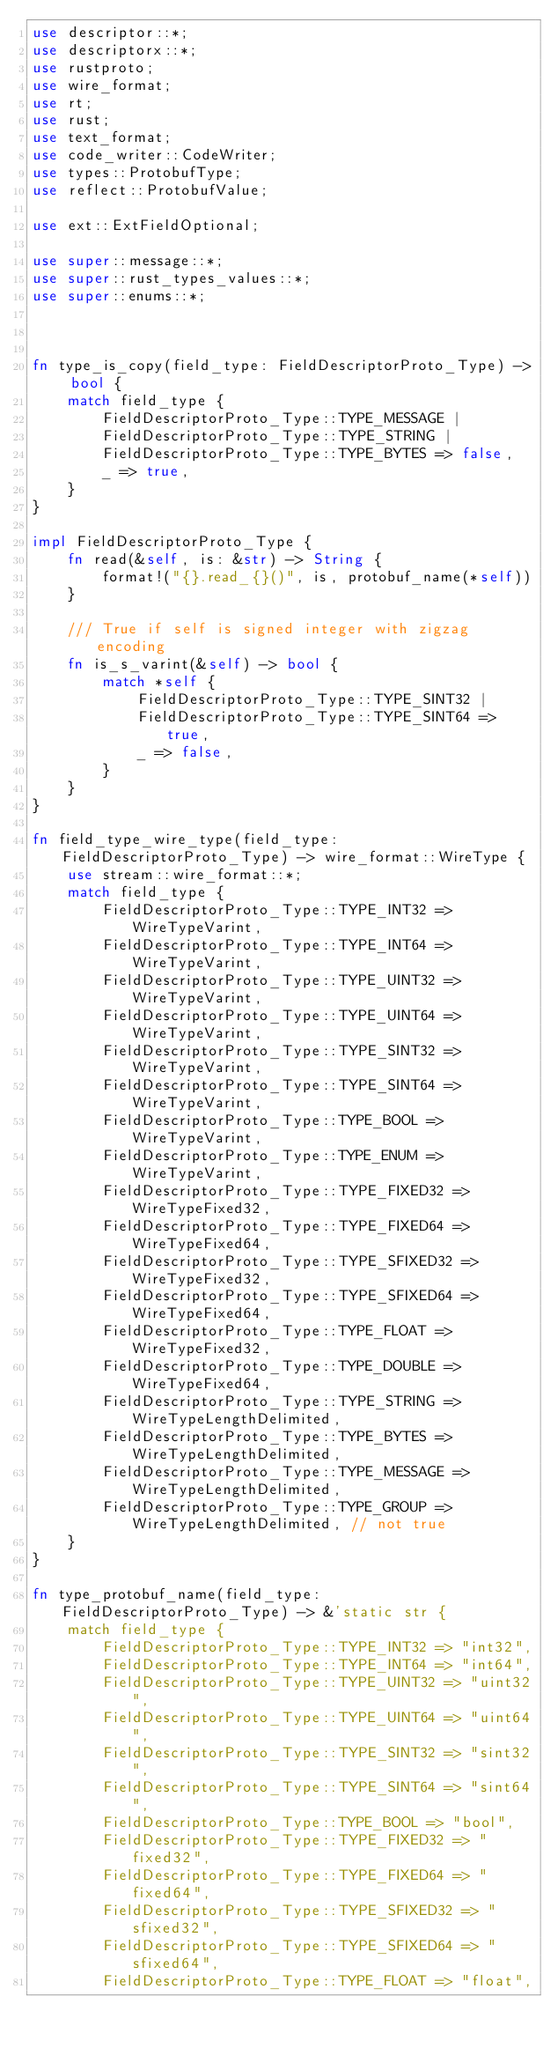Convert code to text. <code><loc_0><loc_0><loc_500><loc_500><_Rust_>use descriptor::*;
use descriptorx::*;
use rustproto;
use wire_format;
use rt;
use rust;
use text_format;
use code_writer::CodeWriter;
use types::ProtobufType;
use reflect::ProtobufValue;

use ext::ExtFieldOptional;

use super::message::*;
use super::rust_types_values::*;
use super::enums::*;



fn type_is_copy(field_type: FieldDescriptorProto_Type) -> bool {
    match field_type {
        FieldDescriptorProto_Type::TYPE_MESSAGE |
        FieldDescriptorProto_Type::TYPE_STRING |
        FieldDescriptorProto_Type::TYPE_BYTES => false,
        _ => true,
    }
}

impl FieldDescriptorProto_Type {
    fn read(&self, is: &str) -> String {
        format!("{}.read_{}()", is, protobuf_name(*self))
    }

    /// True if self is signed integer with zigzag encoding
    fn is_s_varint(&self) -> bool {
        match *self {
            FieldDescriptorProto_Type::TYPE_SINT32 |
            FieldDescriptorProto_Type::TYPE_SINT64 => true,
            _ => false,
        }
    }
}

fn field_type_wire_type(field_type: FieldDescriptorProto_Type) -> wire_format::WireType {
    use stream::wire_format::*;
    match field_type {
        FieldDescriptorProto_Type::TYPE_INT32 => WireTypeVarint,
        FieldDescriptorProto_Type::TYPE_INT64 => WireTypeVarint,
        FieldDescriptorProto_Type::TYPE_UINT32 => WireTypeVarint,
        FieldDescriptorProto_Type::TYPE_UINT64 => WireTypeVarint,
        FieldDescriptorProto_Type::TYPE_SINT32 => WireTypeVarint,
        FieldDescriptorProto_Type::TYPE_SINT64 => WireTypeVarint,
        FieldDescriptorProto_Type::TYPE_BOOL => WireTypeVarint,
        FieldDescriptorProto_Type::TYPE_ENUM => WireTypeVarint,
        FieldDescriptorProto_Type::TYPE_FIXED32 => WireTypeFixed32,
        FieldDescriptorProto_Type::TYPE_FIXED64 => WireTypeFixed64,
        FieldDescriptorProto_Type::TYPE_SFIXED32 => WireTypeFixed32,
        FieldDescriptorProto_Type::TYPE_SFIXED64 => WireTypeFixed64,
        FieldDescriptorProto_Type::TYPE_FLOAT => WireTypeFixed32,
        FieldDescriptorProto_Type::TYPE_DOUBLE => WireTypeFixed64,
        FieldDescriptorProto_Type::TYPE_STRING => WireTypeLengthDelimited,
        FieldDescriptorProto_Type::TYPE_BYTES => WireTypeLengthDelimited,
        FieldDescriptorProto_Type::TYPE_MESSAGE => WireTypeLengthDelimited,
        FieldDescriptorProto_Type::TYPE_GROUP => WireTypeLengthDelimited, // not true
    }
}

fn type_protobuf_name(field_type: FieldDescriptorProto_Type) -> &'static str {
    match field_type {
        FieldDescriptorProto_Type::TYPE_INT32 => "int32",
        FieldDescriptorProto_Type::TYPE_INT64 => "int64",
        FieldDescriptorProto_Type::TYPE_UINT32 => "uint32",
        FieldDescriptorProto_Type::TYPE_UINT64 => "uint64",
        FieldDescriptorProto_Type::TYPE_SINT32 => "sint32",
        FieldDescriptorProto_Type::TYPE_SINT64 => "sint64",
        FieldDescriptorProto_Type::TYPE_BOOL => "bool",
        FieldDescriptorProto_Type::TYPE_FIXED32 => "fixed32",
        FieldDescriptorProto_Type::TYPE_FIXED64 => "fixed64",
        FieldDescriptorProto_Type::TYPE_SFIXED32 => "sfixed32",
        FieldDescriptorProto_Type::TYPE_SFIXED64 => "sfixed64",
        FieldDescriptorProto_Type::TYPE_FLOAT => "float",</code> 